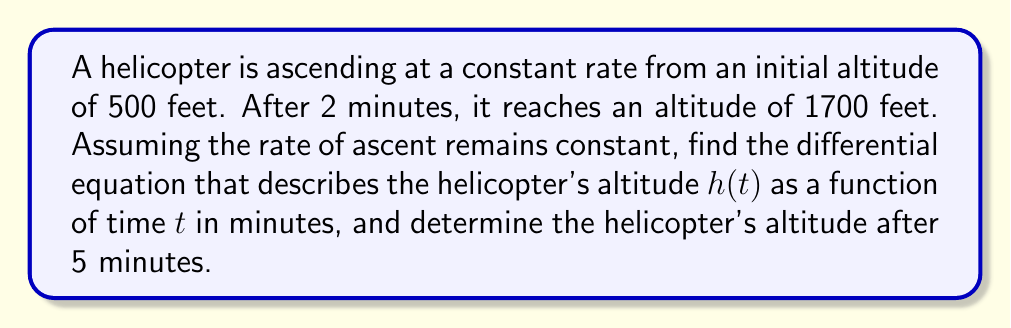Help me with this question. Let's approach this step-by-step:

1) First, we need to determine the rate of ascent. We can do this by calculating the change in altitude over the given time:

   Change in altitude = 1700 ft - 500 ft = 1200 ft
   Time elapsed = 2 minutes

   Rate of ascent = $\frac{1200 \text{ ft}}{2 \text{ min}} = 600 \text{ ft/min}$

2) Now, we can set up our differential equation. The rate of change of altitude with respect to time is constant and equal to 600 ft/min:

   $$\frac{dh}{dt} = 600$$

3) This is a first-order linear differential equation. To solve it, we integrate both sides:

   $$\int dh = \int 600 dt$$

   $$h = 600t + C$$

   where $C$ is the constant of integration.

4) To find $C$, we use the initial condition. At $t=0$, $h=500$:

   $500 = 600(0) + C$
   $C = 500$

5) Therefore, our complete solution is:

   $$h(t) = 600t + 500$$

6) To find the altitude after 5 minutes, we simply plug in $t=5$:

   $h(5) = 600(5) + 500 = 3000 + 500 = 3500$

Thus, after 5 minutes, the helicopter will be at an altitude of 3500 feet.
Answer: The differential equation is $\frac{dh}{dt} = 600$ with solution $h(t) = 600t + 500$, where $h$ is in feet and $t$ is in minutes. After 5 minutes, the helicopter's altitude will be 3500 feet. 